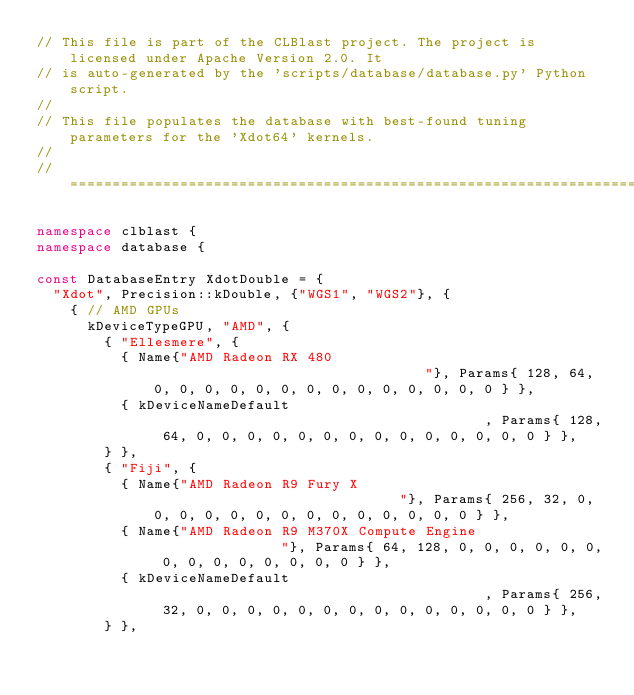<code> <loc_0><loc_0><loc_500><loc_500><_C++_>// This file is part of the CLBlast project. The project is licensed under Apache Version 2.0. It
// is auto-generated by the 'scripts/database/database.py' Python script.
//
// This file populates the database with best-found tuning parameters for the 'Xdot64' kernels.
//
// =================================================================================================

namespace clblast {
namespace database {

const DatabaseEntry XdotDouble = {
  "Xdot", Precision::kDouble, {"WGS1", "WGS2"}, {
    { // AMD GPUs
      kDeviceTypeGPU, "AMD", {
        { "Ellesmere", {
          { Name{"AMD Radeon RX 480                                 "}, Params{ 128, 64, 0, 0, 0, 0, 0, 0, 0, 0, 0, 0, 0, 0, 0, 0 } },
          { kDeviceNameDefault                                        , Params{ 128, 64, 0, 0, 0, 0, 0, 0, 0, 0, 0, 0, 0, 0, 0, 0 } },
        } },
        { "Fiji", {
          { Name{"AMD Radeon R9 Fury X                              "}, Params{ 256, 32, 0, 0, 0, 0, 0, 0, 0, 0, 0, 0, 0, 0, 0, 0 } },
          { Name{"AMD Radeon R9 M370X Compute Engine                "}, Params{ 64, 128, 0, 0, 0, 0, 0, 0, 0, 0, 0, 0, 0, 0, 0, 0 } },
          { kDeviceNameDefault                                        , Params{ 256, 32, 0, 0, 0, 0, 0, 0, 0, 0, 0, 0, 0, 0, 0, 0 } },
        } },</code> 